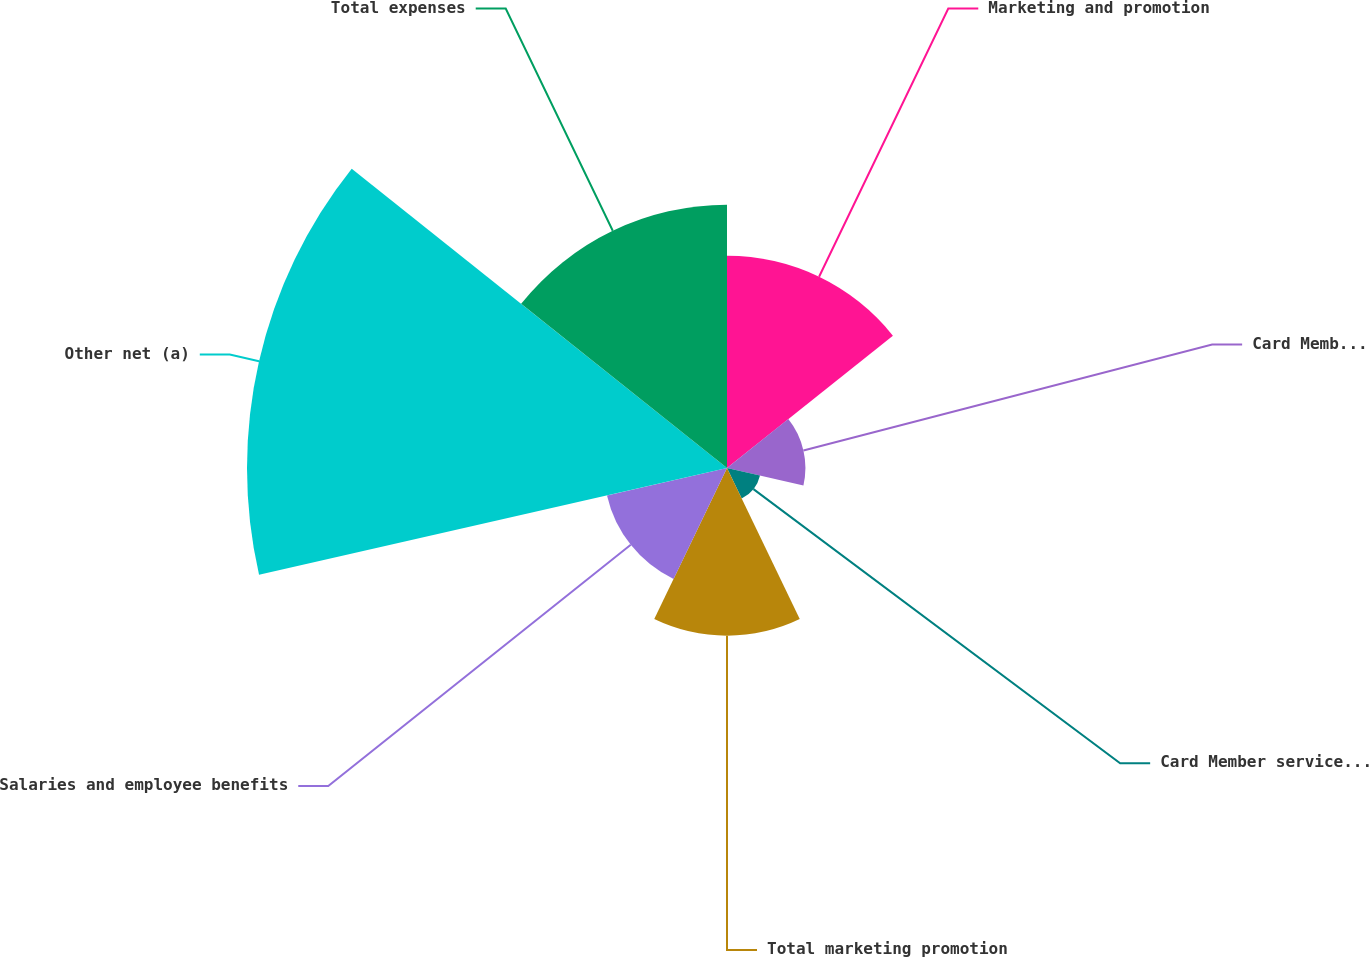Convert chart. <chart><loc_0><loc_0><loc_500><loc_500><pie_chart><fcel>Marketing and promotion<fcel>Card Member rewards<fcel>Card Member services and other<fcel>Total marketing promotion<fcel>Salaries and employee benefits<fcel>Other net (a)<fcel>Total expenses<nl><fcel>15.62%<fcel>5.77%<fcel>2.49%<fcel>12.34%<fcel>9.06%<fcel>35.33%<fcel>19.38%<nl></chart> 